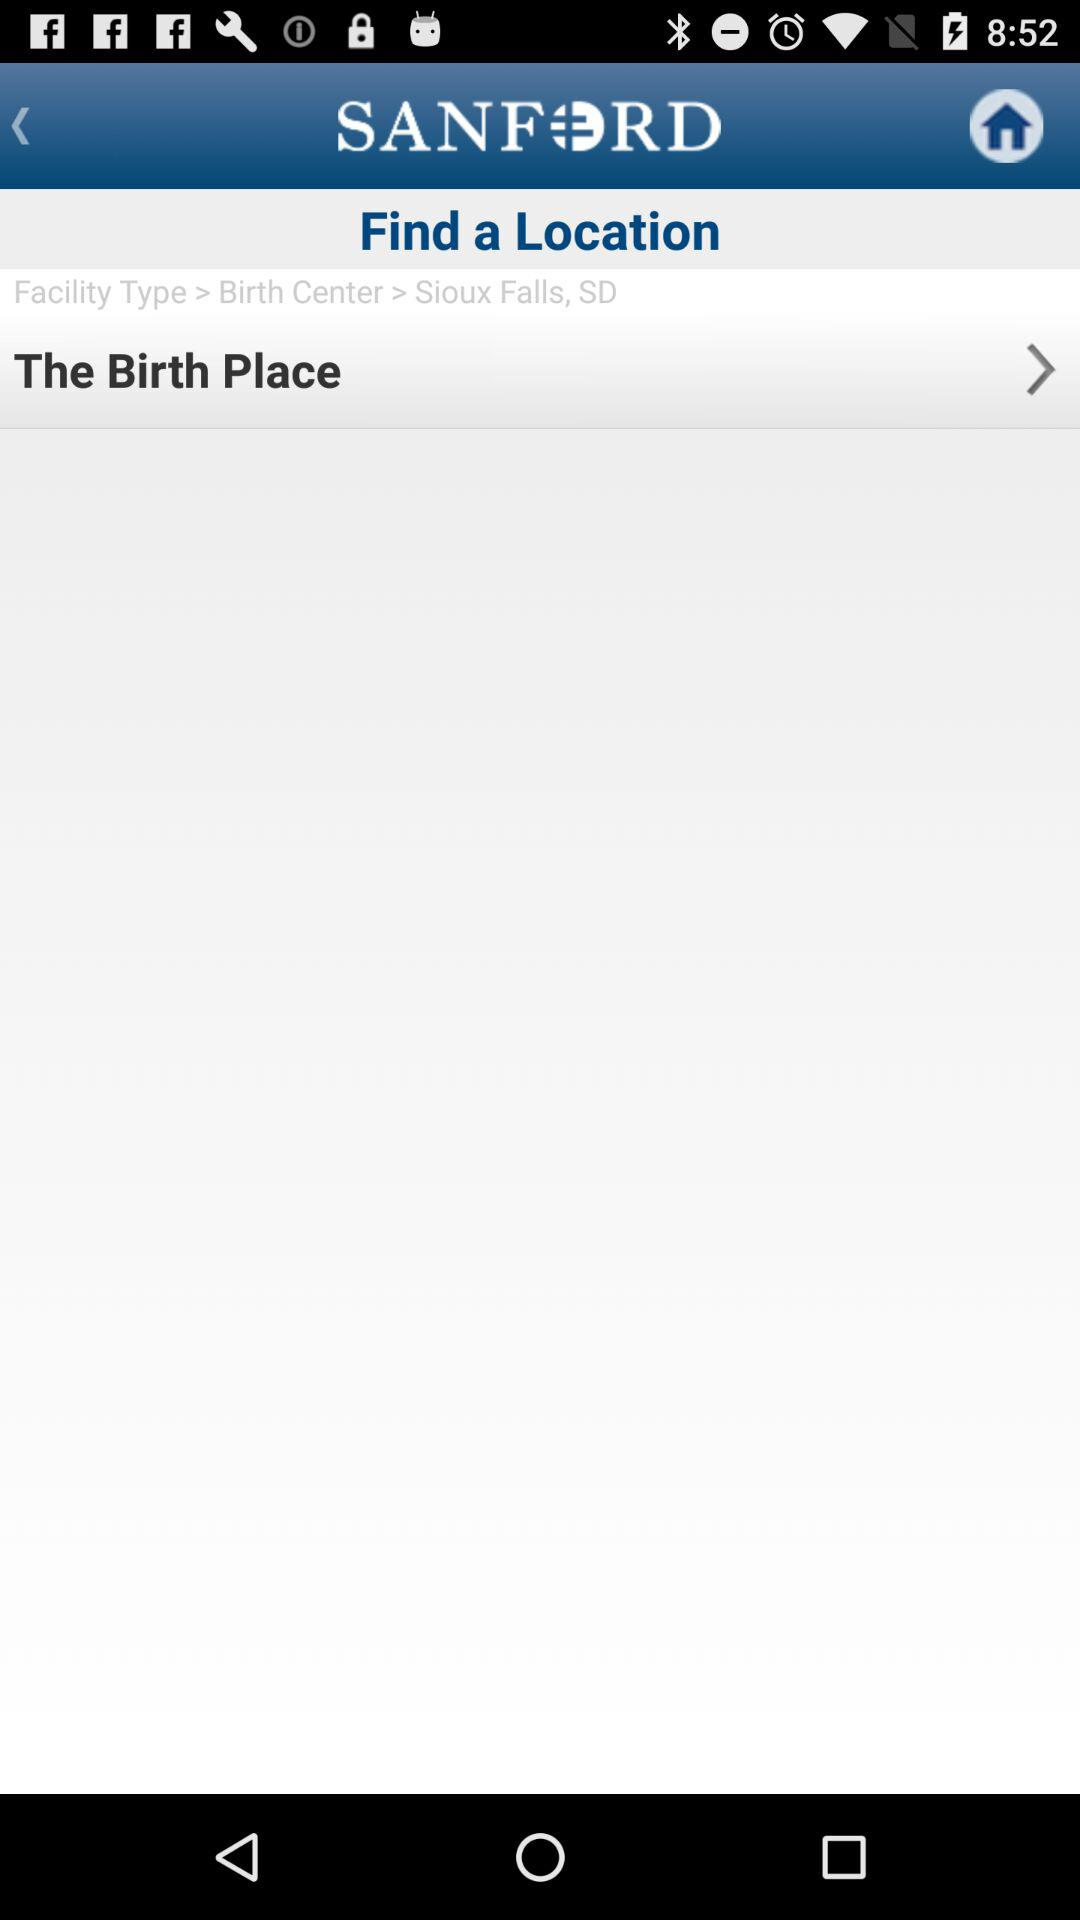What is the current location?
When the provided information is insufficient, respond with <no answer>. <no answer> 